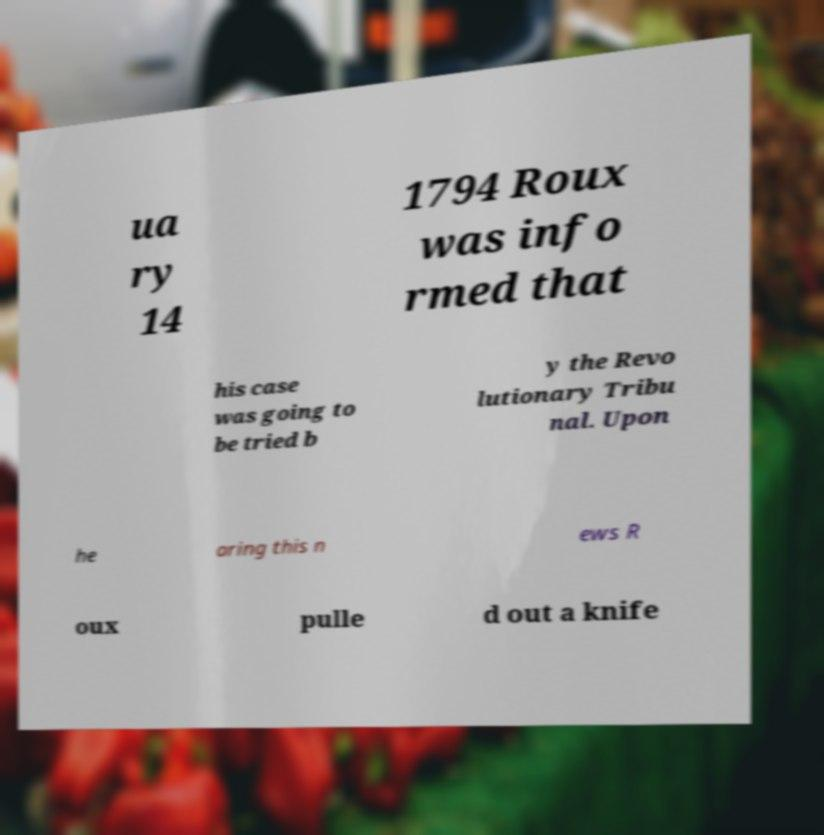There's text embedded in this image that I need extracted. Can you transcribe it verbatim? ua ry 14 1794 Roux was info rmed that his case was going to be tried b y the Revo lutionary Tribu nal. Upon he aring this n ews R oux pulle d out a knife 